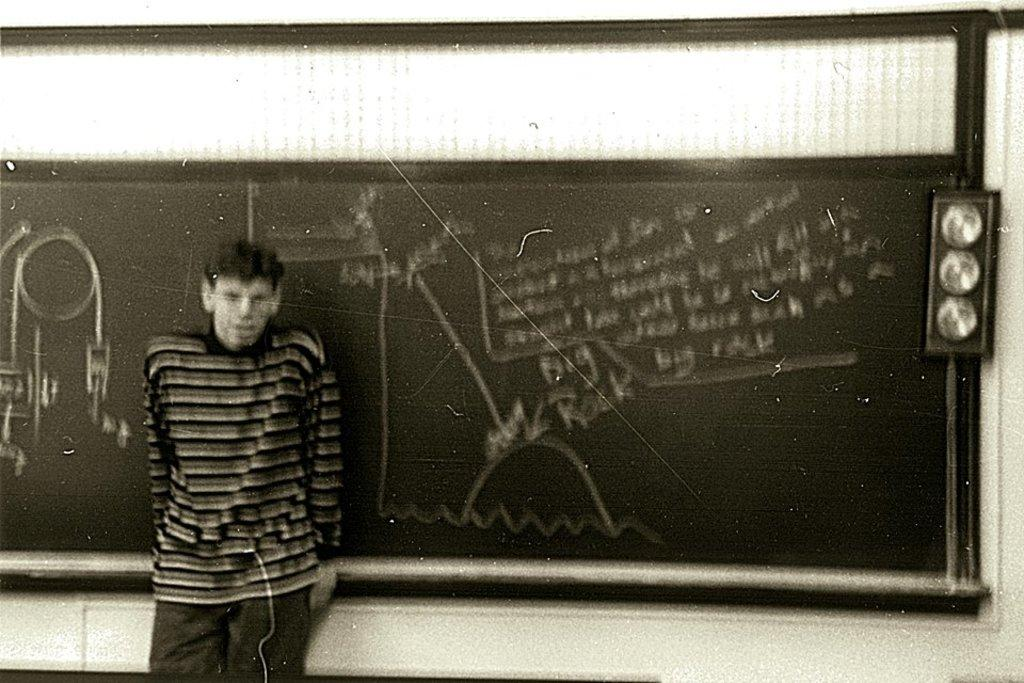What is the main subject in the foreground of the image? There is a person standing near the blackboard in the foreground. What can be seen in the background of the image? The background of the image is white. What type of veil is the person wearing in the image? There is no veil present in the image; the person is standing near a blackboard. 